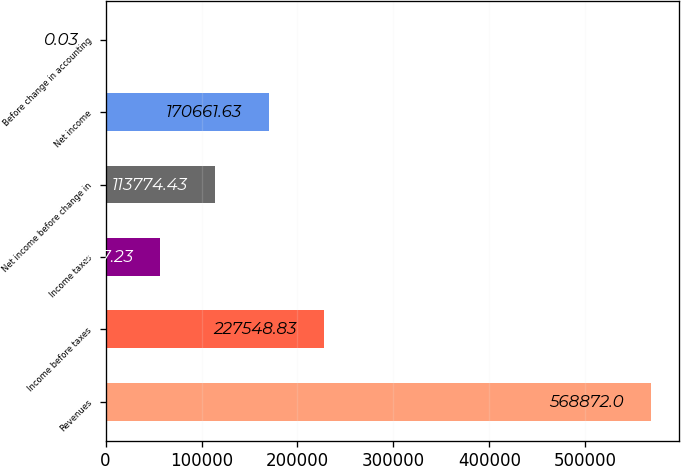<chart> <loc_0><loc_0><loc_500><loc_500><bar_chart><fcel>Revenues<fcel>Income before taxes<fcel>Income taxes<fcel>Net income before change in<fcel>Net income<fcel>Before change in accounting<nl><fcel>568872<fcel>227549<fcel>56887.2<fcel>113774<fcel>170662<fcel>0.03<nl></chart> 